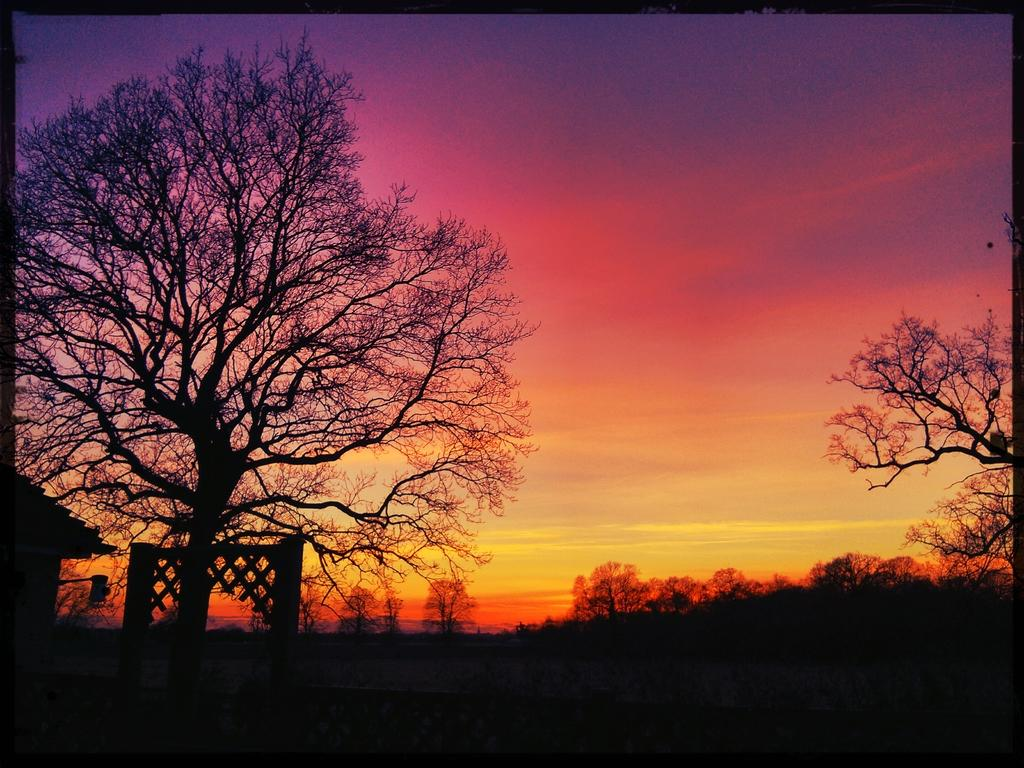What type of vegetation can be seen in the image? There are dried trees in the image. What structure is present in the image? There is a building in the image. What colors can be seen in the sky in the background? The sky in the background has purple, orange, and yellow colors. How many daughters are present in the image? There is no mention of a daughter or any people in the image; it features dried trees, a building, and a colorful sky. Is there a farm visible in the image? There is no farm present in the image; it features dried trees, a building, and a colorful sky. 